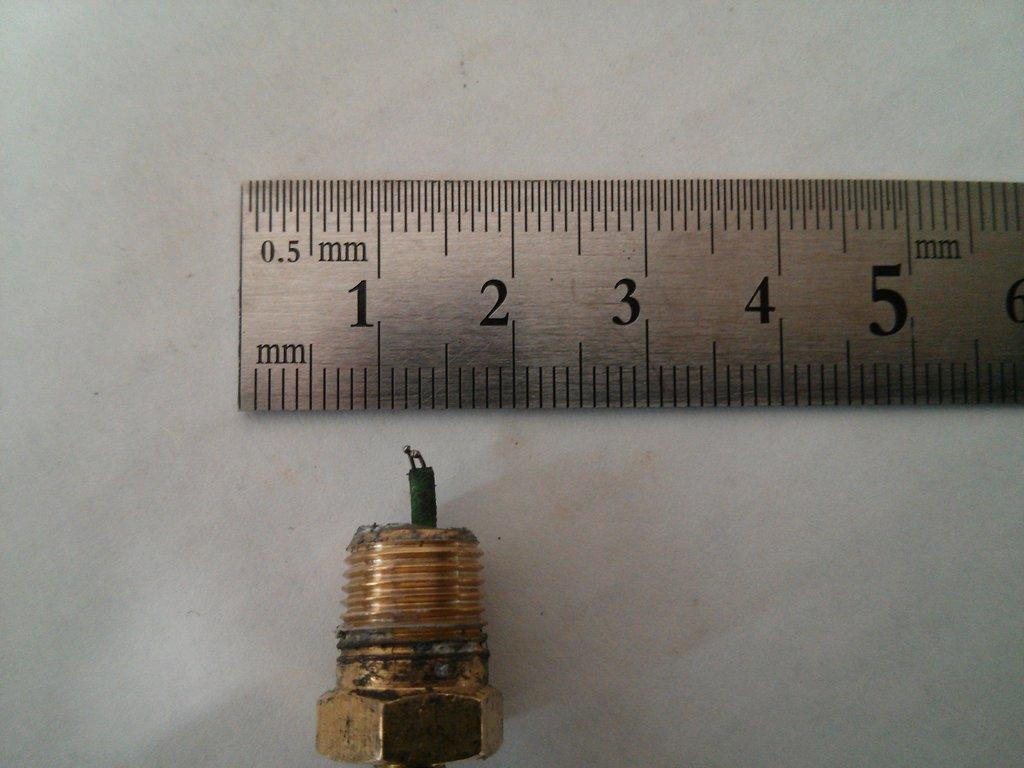Provide a one-sentence caption for the provided image. A metal ruler showing the scale of a bolt and wire. 